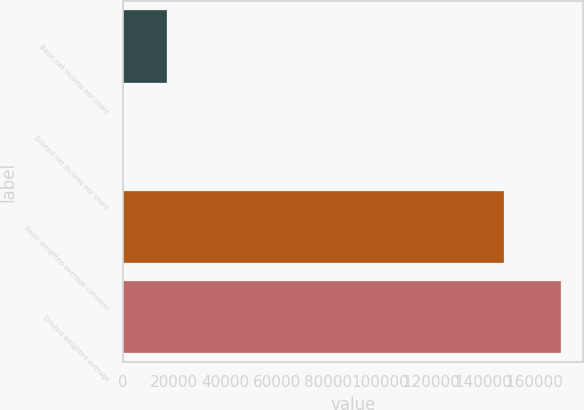Convert chart to OTSL. <chart><loc_0><loc_0><loc_500><loc_500><bar_chart><fcel>Basic net income per share<fcel>Diluted net income per share<fcel>Basic weighted average common<fcel>Diluted weighted average<nl><fcel>17030.6<fcel>0.16<fcel>148293<fcel>170305<nl></chart> 